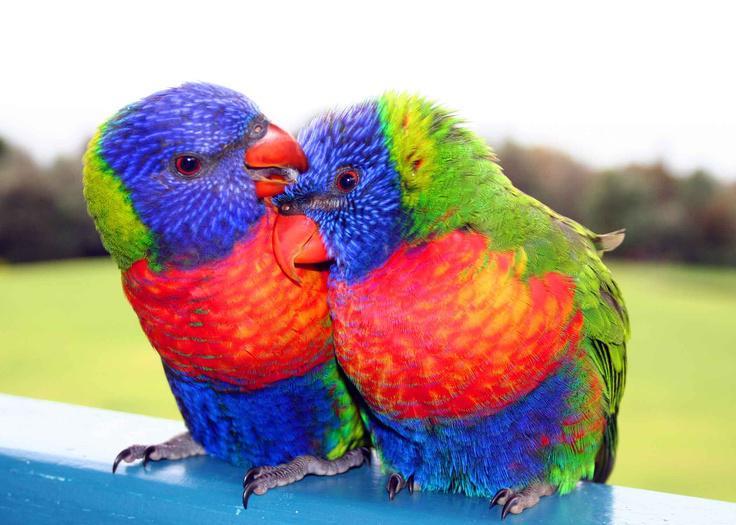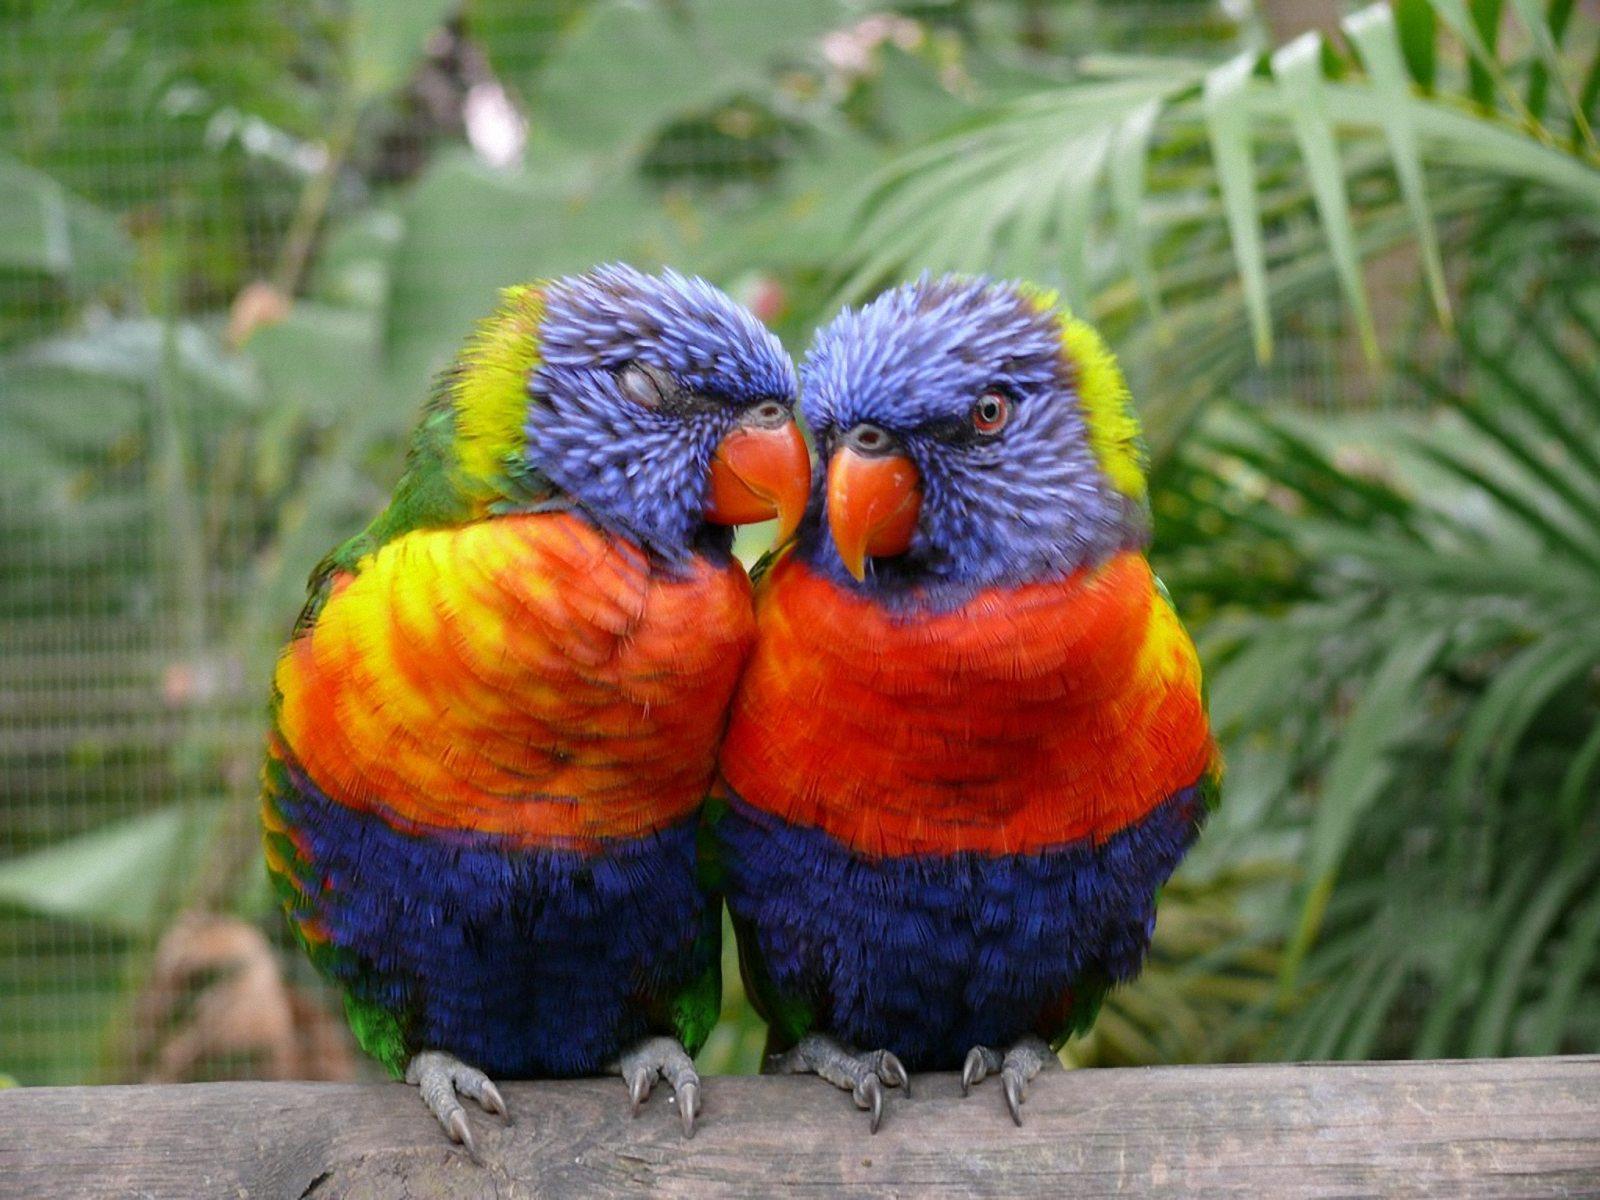The first image is the image on the left, the second image is the image on the right. Assess this claim about the two images: "Exactly four parrots are shown, one pair of similar coloring in each image, with one pair in or near vegetation.". Correct or not? Answer yes or no. Yes. The first image is the image on the left, the second image is the image on the right. Evaluate the accuracy of this statement regarding the images: "Four colorful birds are perched outside.". Is it true? Answer yes or no. Yes. 